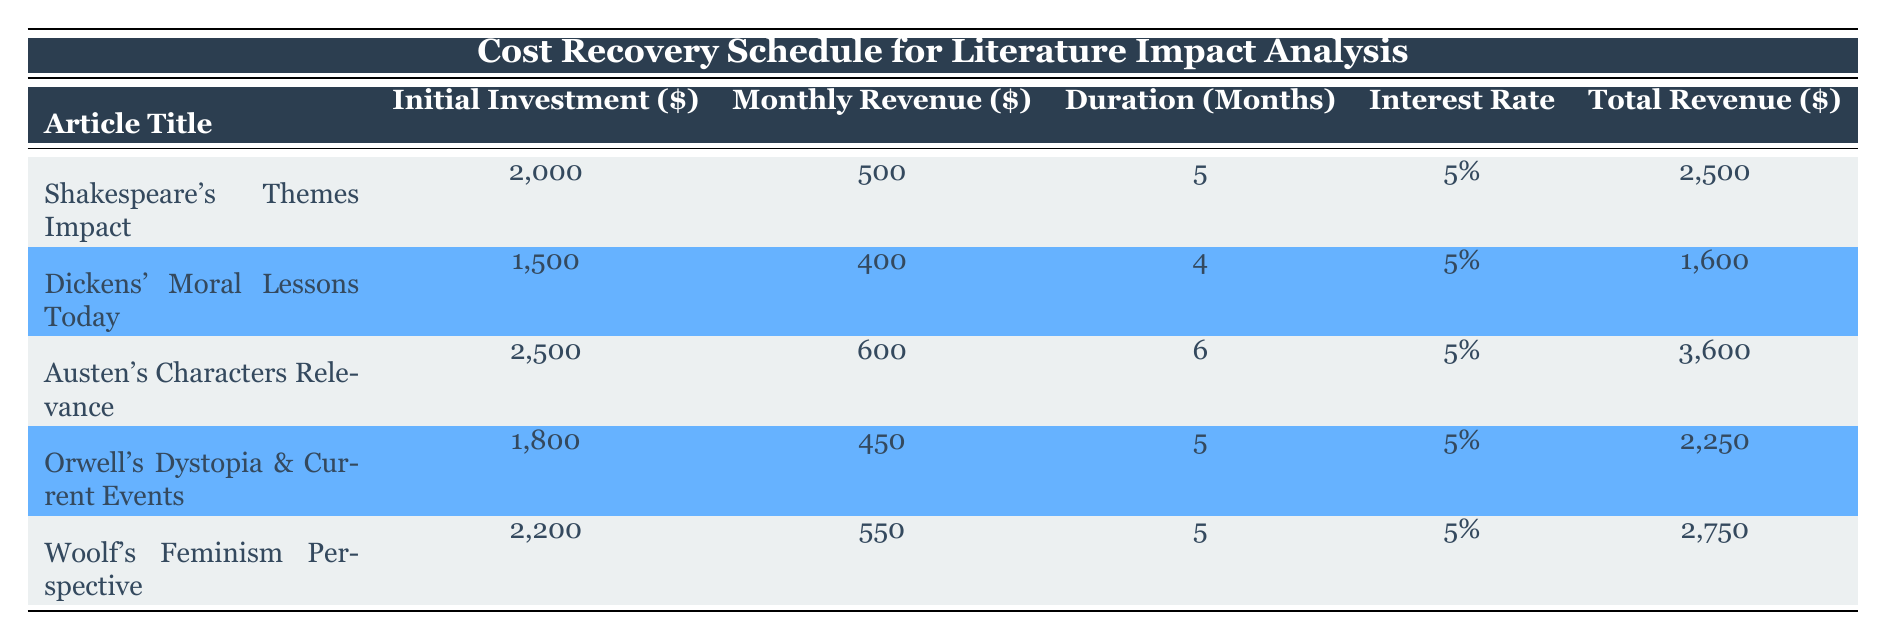What is the initial investment for the article titled "How Orwell's Dystopia Mirrors Current Events"? The table specifies the initial investment directly under the relevant column. For "How Orwell's Dystopia Mirrors Current Events," the initial investment is listed as 1800.
Answer: 1800 What is the total revenue generated by the article "The Relevance of Austen's Characters in Contemporary Relationships"? To find the total revenue for this article, we refer to the corresponding value in the "Total Revenue ($)" column. The total revenue for this article is listed as 3600.
Answer: 3600 How many months is the duration for the article examining "Feminism in the Works of Virginia Woolf"? The duration is listed directly in the table under the "Duration (Months)" column for this article, which shows 5 months.
Answer: 5 Which article has the highest monthly revenue? We compare the "Monthly Revenue ($)" values for each article. "The Relevance of Austen's Characters in Contemporary Relationships" has the highest monthly revenue at 600.
Answer: The Relevance of Austen's Characters in Contemporary Relationships What is the total investment for all articles combined? The total investment is the sum of all initial investments across the articles. Adding them gives us: 2000 + 1500 + 2500 + 1800 + 2200 = 11000.
Answer: 11000 Is the interest rate the same for all articles? Inspecting the "Interest Rate" column shows that all articles have an interest rate listed as 5%. Therefore, the statement is true.
Answer: Yes Which article has the lowest initial investment, and what is its value? To identify this, we check the "Initial Investment ($)" column. The lowest value is for "Dickens' Moral Lessons Today," which has an investment of 1500.
Answer: Dickens' Moral Lessons Today, 1500 What is the average total revenue generated by the articles? The total revenues are: 2500, 1600, 3600, 2250, and 2750. The sum is 2500 + 1600 + 3600 + 2250 + 2750 = 13700. Dividing by 5 articles gives an average of 2740.
Answer: 2740 Which article has the duration month of 4? By reviewing the "Duration (Months)" column, we find "Exploring the Moral Lessons of Dickens in Today's Society" has a duration of 4 months.
Answer: Exploring the Moral Lessons of Dickens in Today's Society 